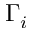Convert formula to latex. <formula><loc_0><loc_0><loc_500><loc_500>\Gamma _ { i }</formula> 